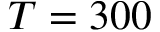Convert formula to latex. <formula><loc_0><loc_0><loc_500><loc_500>T = 3 0 0</formula> 